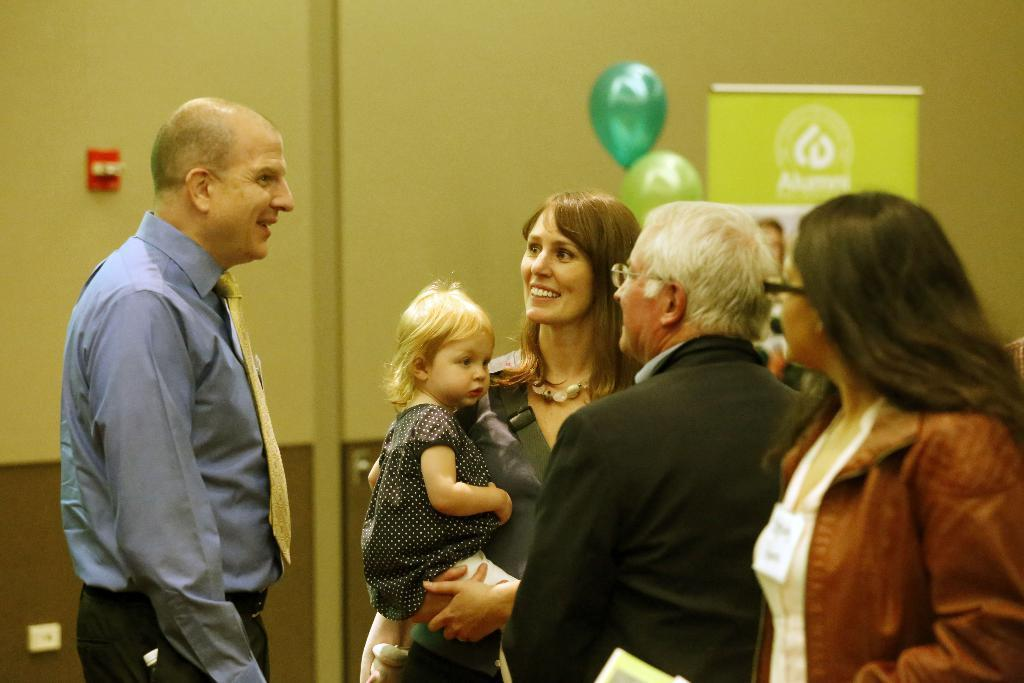What is happening in the image involving the people? There are people standing in the image, including a woman who is carrying a child. What can be seen in the background of the image? There is a board visible in the image. What decorative items are present in the image? Balloons are present in the image. What is attached to the wall in the image? There is a switchboard on the wall in the image. What type of country is mentioned on the list in the image? There is no list present in the image, so it cannot be determined if a country is mentioned. Can you see any worms crawling on the switchboard in the image? There are no worms present in the image, so it cannot be determined if any are crawling on the switchboard. 